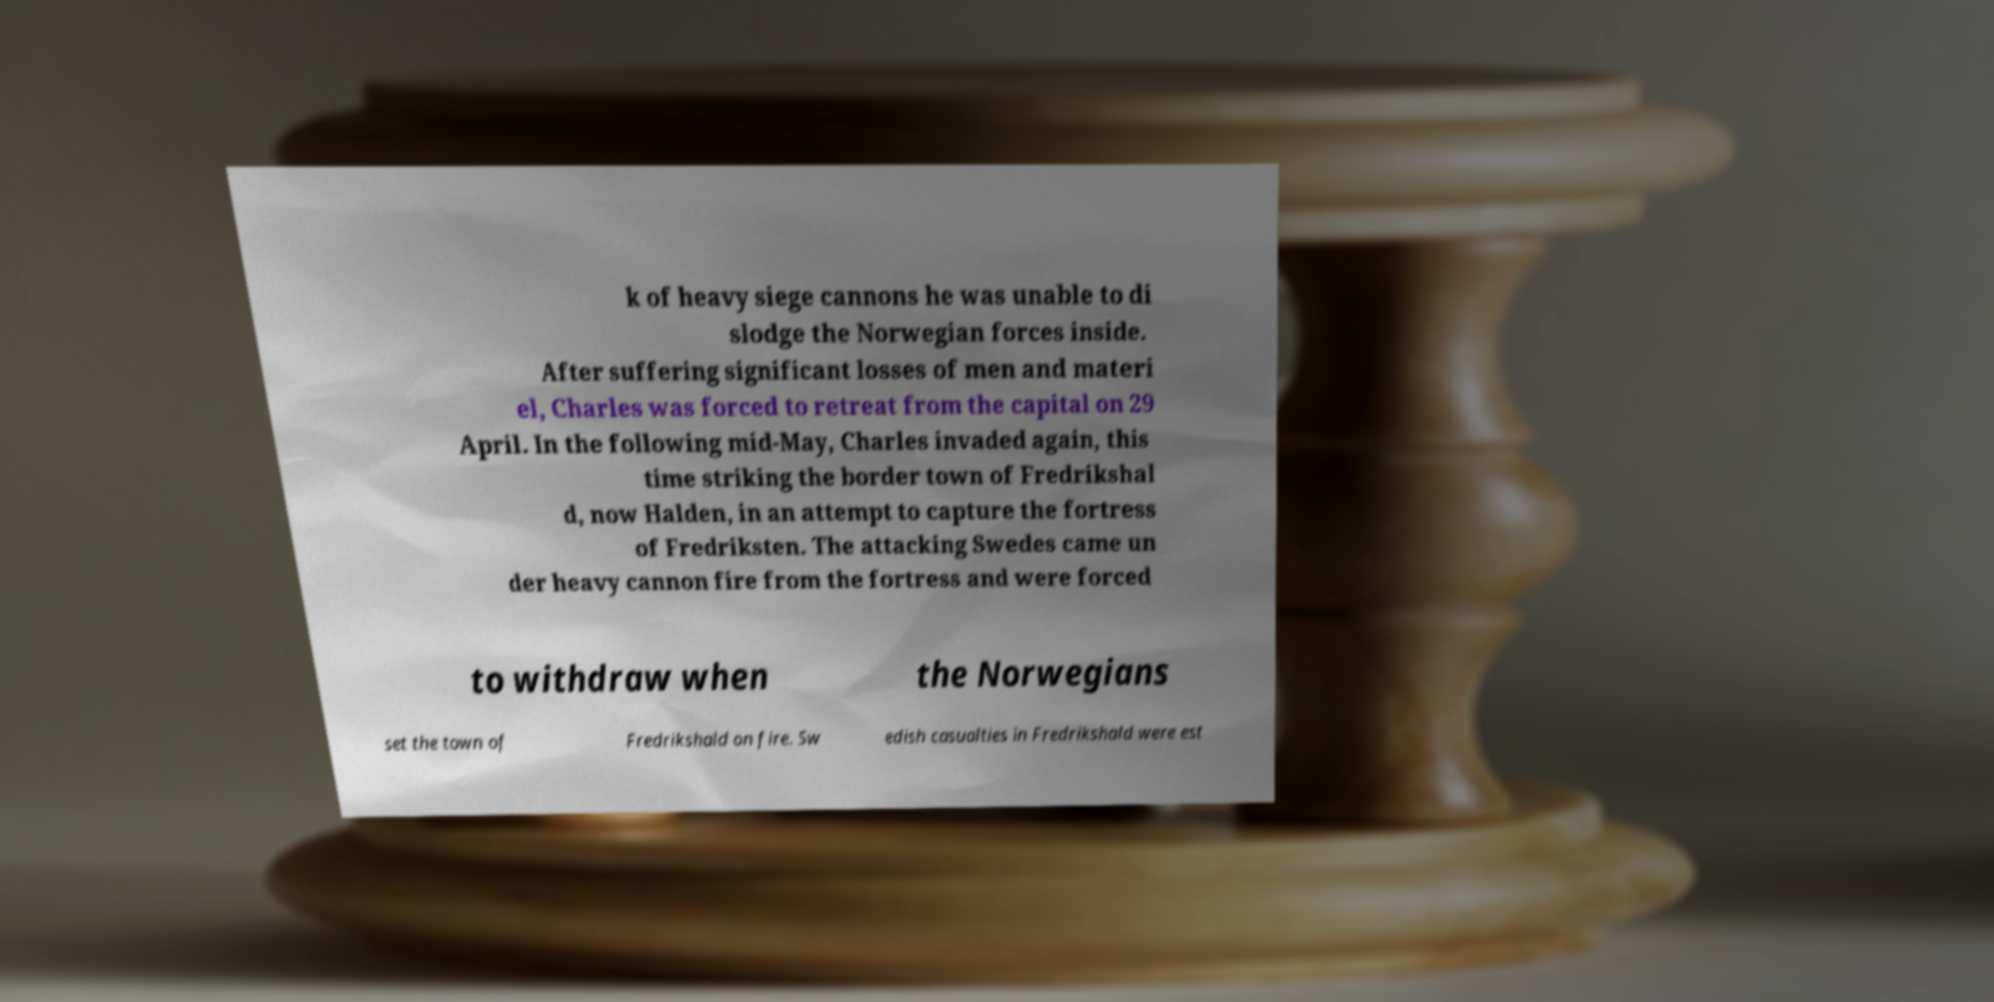Could you extract and type out the text from this image? k of heavy siege cannons he was unable to di slodge the Norwegian forces inside. After suffering significant losses of men and materi el, Charles was forced to retreat from the capital on 29 April. In the following mid-May, Charles invaded again, this time striking the border town of Fredrikshal d, now Halden, in an attempt to capture the fortress of Fredriksten. The attacking Swedes came un der heavy cannon fire from the fortress and were forced to withdraw when the Norwegians set the town of Fredrikshald on fire. Sw edish casualties in Fredrikshald were est 